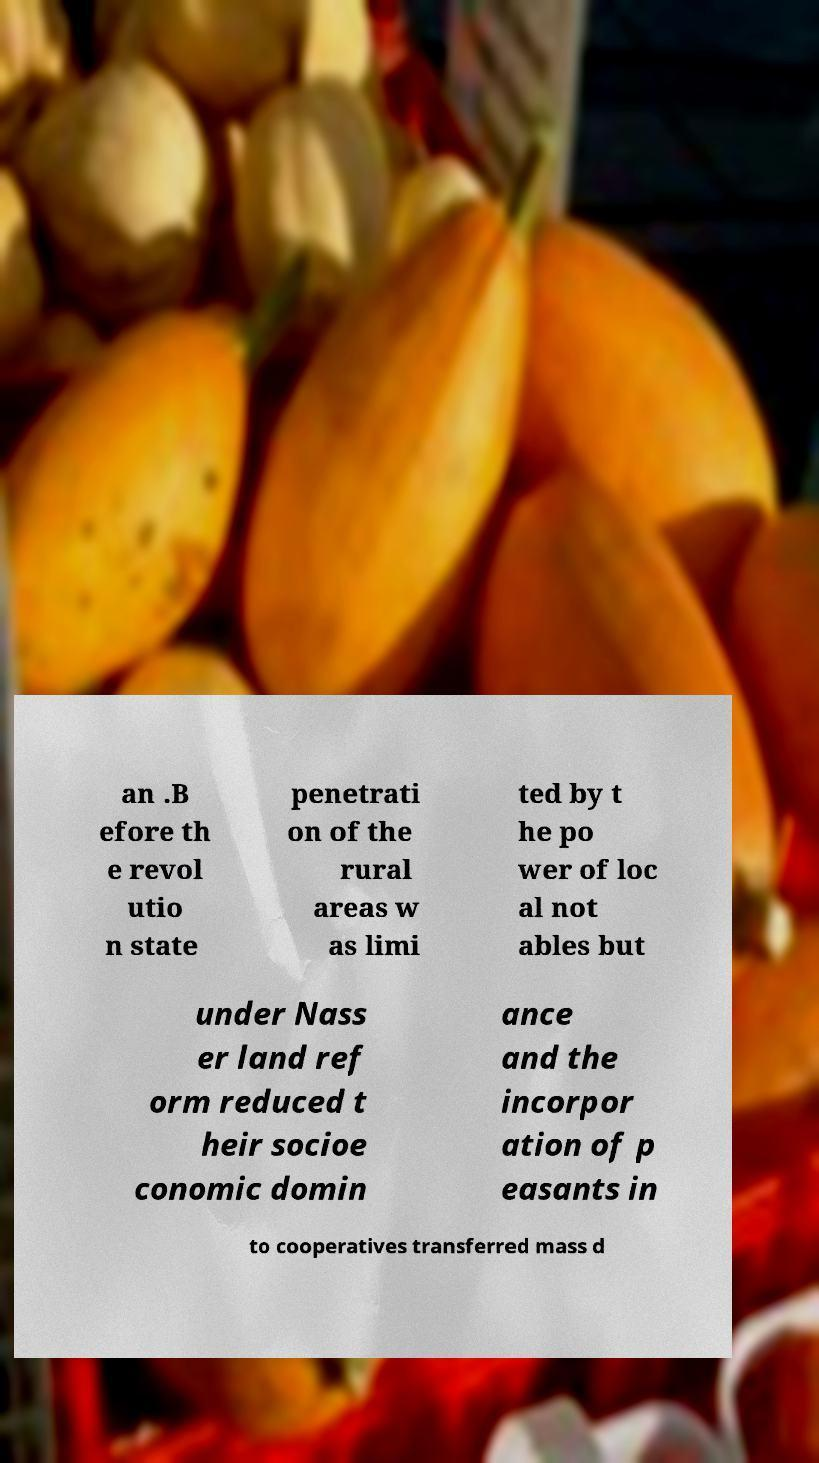There's text embedded in this image that I need extracted. Can you transcribe it verbatim? an .B efore th e revol utio n state penetrati on of the rural areas w as limi ted by t he po wer of loc al not ables but under Nass er land ref orm reduced t heir socioe conomic domin ance and the incorpor ation of p easants in to cooperatives transferred mass d 